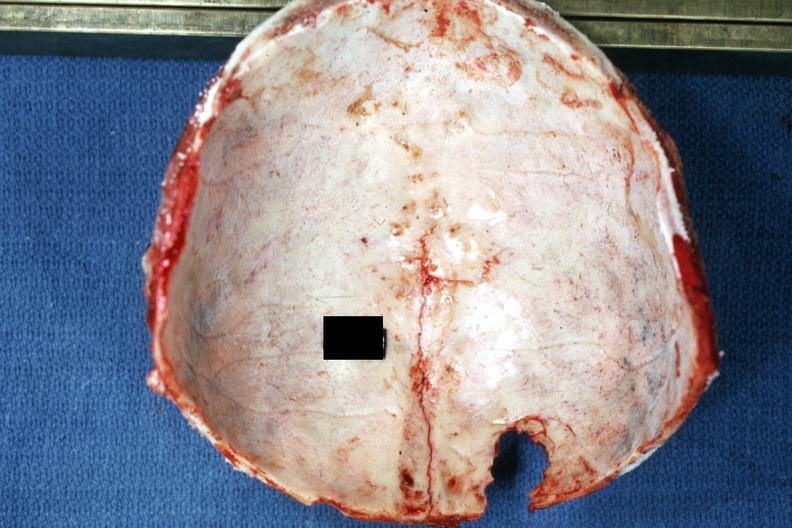s thecoma present?
Answer the question using a single word or phrase. No 